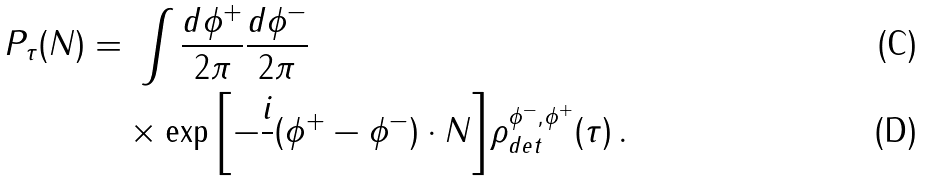<formula> <loc_0><loc_0><loc_500><loc_500>P _ { \tau } ( N ) = & \ \int \frac { d \phi ^ { + } } { 2 \pi } \frac { d \phi ^ { - } } { 2 \pi } \\ & \times \exp { \left [ - \frac { i } { } ( \phi ^ { + } - \phi ^ { - } ) \cdot N \right ] } { \rho } ^ { \phi ^ { - } , \phi ^ { + } } _ { d e t } ( \tau ) \, .</formula> 